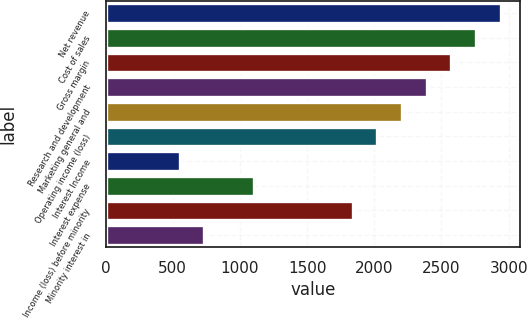Convert chart. <chart><loc_0><loc_0><loc_500><loc_500><bar_chart><fcel>Net revenue<fcel>Cost of sales<fcel>Gross margin<fcel>Research and development<fcel>Marketing general and<fcel>Operating income (loss)<fcel>Interest Income<fcel>Interest expense<fcel>Income (loss) before minority<fcel>Minority interest in<nl><fcel>2940.69<fcel>2756.91<fcel>2573.13<fcel>2389.35<fcel>2205.57<fcel>2021.79<fcel>551.55<fcel>1102.89<fcel>1838.01<fcel>735.33<nl></chart> 